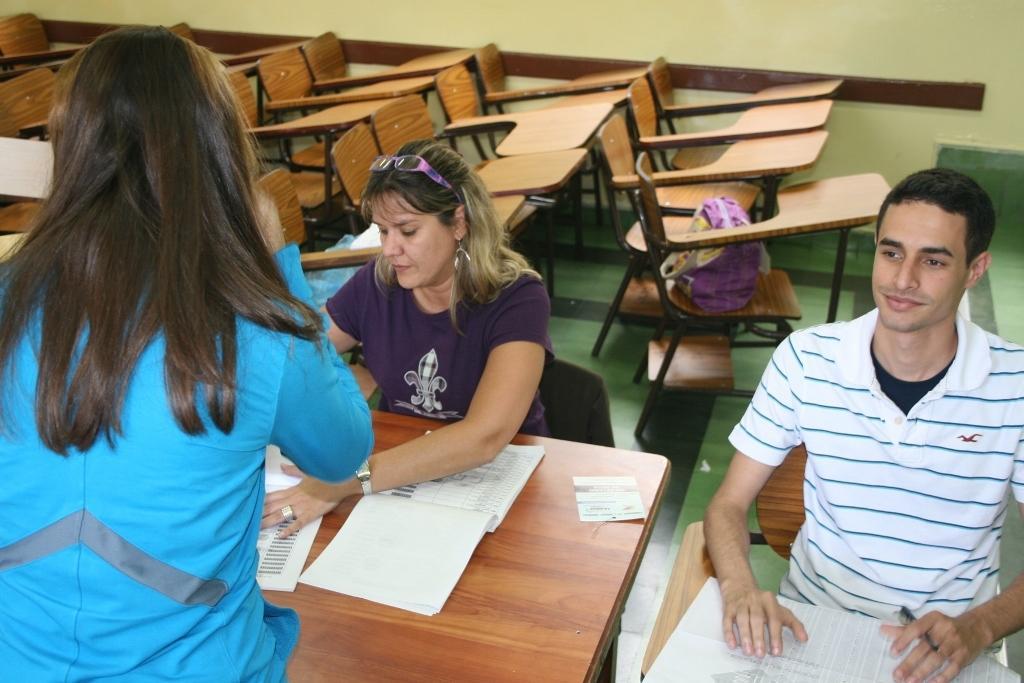How would you summarize this image in a sentence or two? There are three persons. A man on the right side is holding pen. In front of him there is a paper. A woman wearing violet t shirt and goggles is sitting on chair. There is a table. On the table there are books. In the background there are many chairs and wall. On the chair there is a pink bag. 